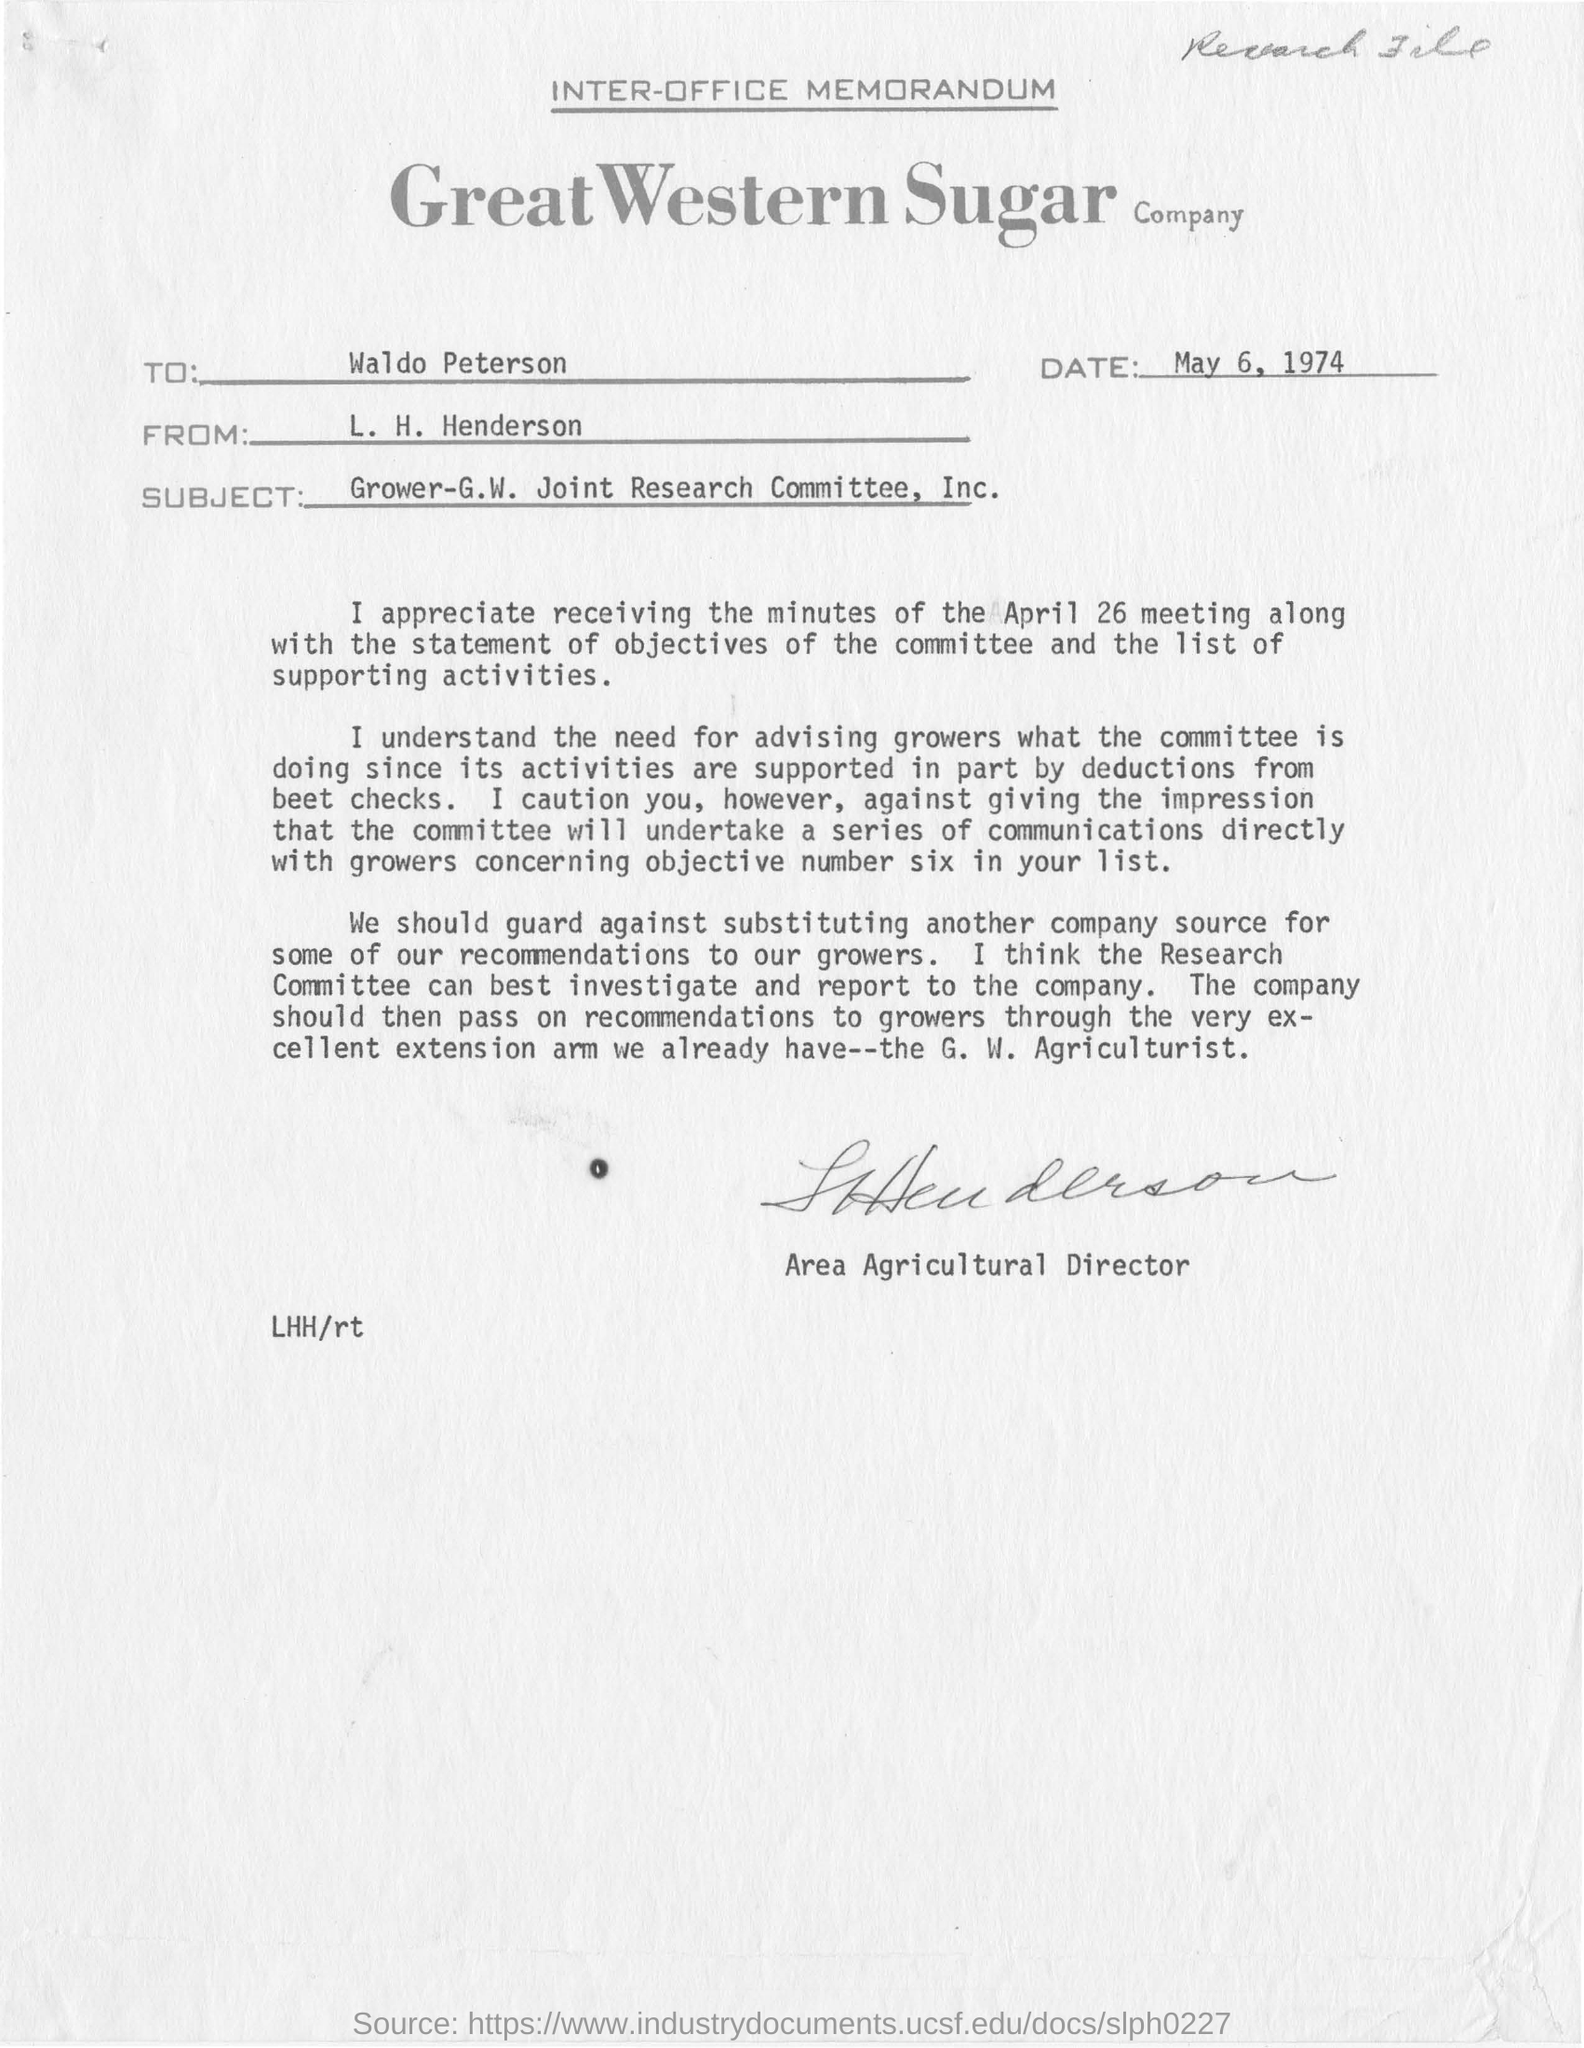Highlight a few significant elements in this photo. The memorandum is addressed to Waldo Peterson. The sender of this memorandum is L. H. Henderson. 